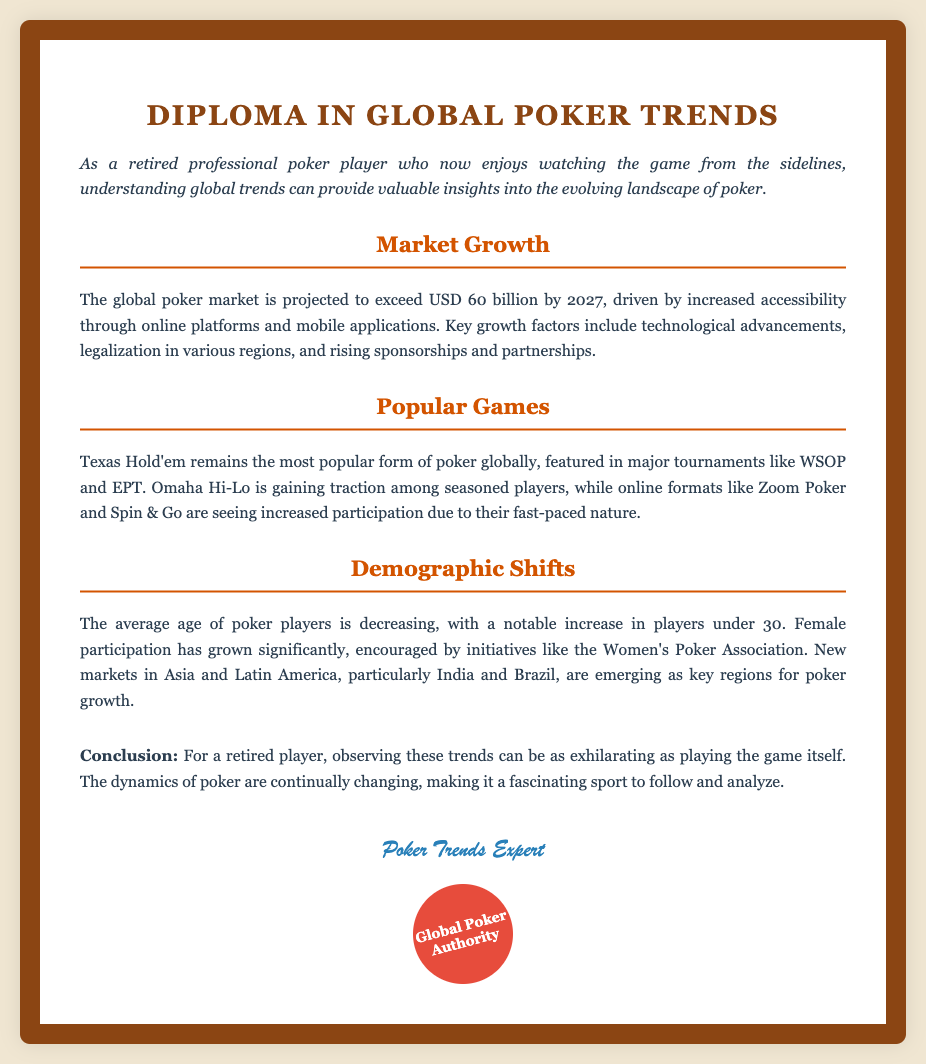what is the projected global poker market value by 2027? The document states that the global poker market is projected to exceed USD 60 billion by 2027.
Answer: USD 60 billion which poker game is identified as the most popular globally? According to the document, Texas Hold'em remains the most popular form of poker globally.
Answer: Texas Hold'em what has contributed to the recent growth in female poker participation? The document mentions that initiatives like the Women's Poker Association have encouraged female participation.
Answer: Women's Poker Association what is the average age trend of poker players? The document indicates that the average age of poker players is decreasing, with an increase in players under 30.
Answer: Decreasing which two emerging regions are noted for poker growth? The document highlights new markets in Asia and Latin America, particularly India and Brazil.
Answer: India and Brazil what is a fast-paced online poker format mentioned in the document? The document states that formats like Zoom Poker and Spin & Go are seeing increased participation due to their fast-paced nature.
Answer: Zoom Poker what signifies the growing accessibility in poker? The document credits increased accessibility to the rise of online platforms and mobile applications.
Answer: Online platforms and mobile applications who is the author of the diploma? The signature at the end of the diploma identifies the author as a "Poker Trends Expert."
Answer: Poker Trends Expert 